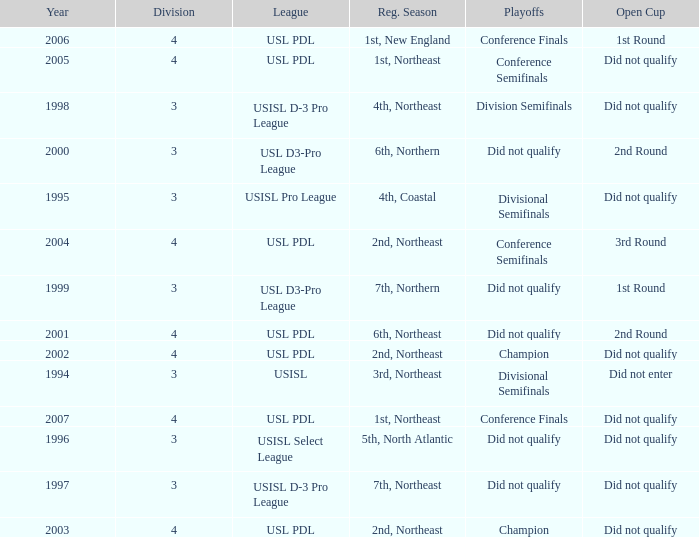Mame the reg season for 2001 6th, Northeast. 